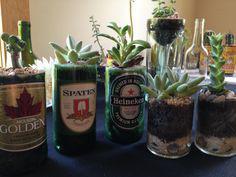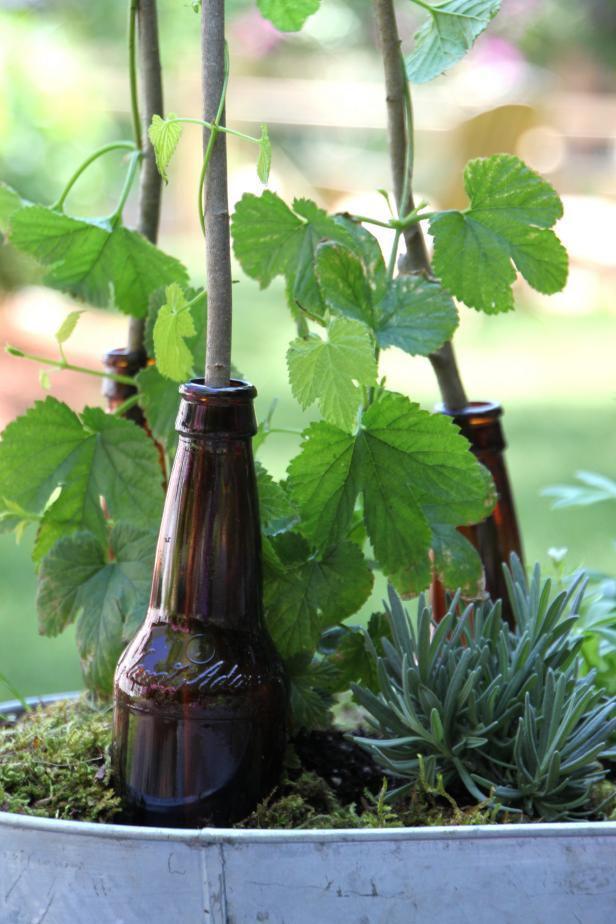The first image is the image on the left, the second image is the image on the right. Evaluate the accuracy of this statement regarding the images: "In at least one image there are three brown bottles with tree starting to grow out of it.". Is it true? Answer yes or no. Yes. The first image is the image on the left, the second image is the image on the right. Examine the images to the left and right. Is the description "A single bottle in the image on the right is positioned upside down." accurate? Answer yes or no. No. 